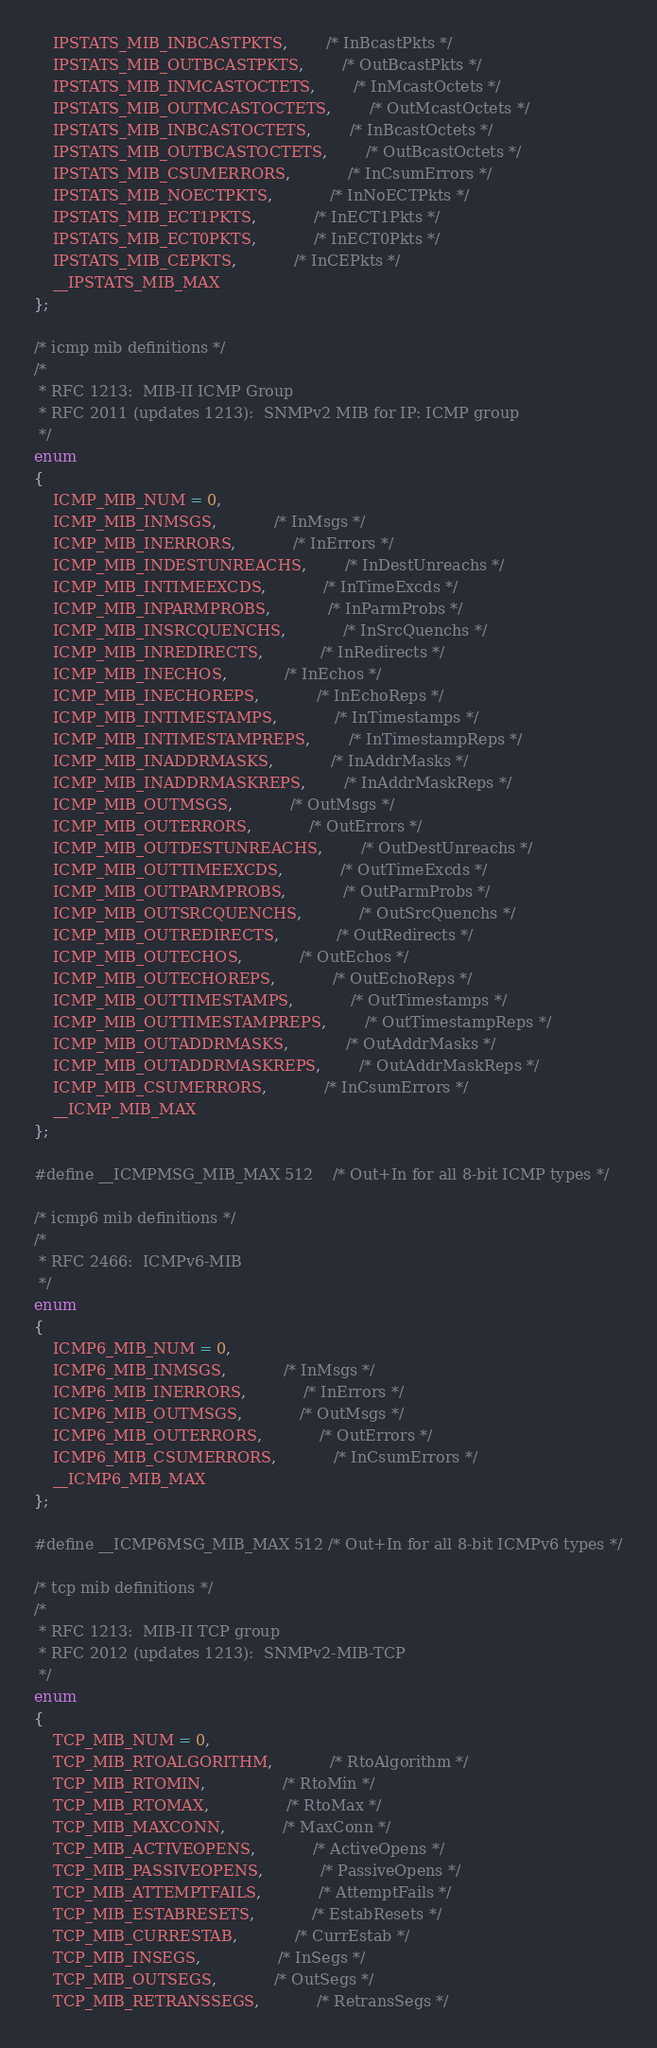<code> <loc_0><loc_0><loc_500><loc_500><_C_>	IPSTATS_MIB_INBCASTPKTS,		/* InBcastPkts */
	IPSTATS_MIB_OUTBCASTPKTS,		/* OutBcastPkts */
	IPSTATS_MIB_INMCASTOCTETS,		/* InMcastOctets */
	IPSTATS_MIB_OUTMCASTOCTETS,		/* OutMcastOctets */
	IPSTATS_MIB_INBCASTOCTETS,		/* InBcastOctets */
	IPSTATS_MIB_OUTBCASTOCTETS,		/* OutBcastOctets */
	IPSTATS_MIB_CSUMERRORS,			/* InCsumErrors */
	IPSTATS_MIB_NOECTPKTS,			/* InNoECTPkts */
	IPSTATS_MIB_ECT1PKTS,			/* InECT1Pkts */
	IPSTATS_MIB_ECT0PKTS,			/* InECT0Pkts */
	IPSTATS_MIB_CEPKTS,			/* InCEPkts */
	__IPSTATS_MIB_MAX
};

/* icmp mib definitions */
/*
 * RFC 1213:  MIB-II ICMP Group
 * RFC 2011 (updates 1213):  SNMPv2 MIB for IP: ICMP group
 */
enum
{
	ICMP_MIB_NUM = 0,
	ICMP_MIB_INMSGS,			/* InMsgs */
	ICMP_MIB_INERRORS,			/* InErrors */
	ICMP_MIB_INDESTUNREACHS,		/* InDestUnreachs */
	ICMP_MIB_INTIMEEXCDS,			/* InTimeExcds */
	ICMP_MIB_INPARMPROBS,			/* InParmProbs */
	ICMP_MIB_INSRCQUENCHS,			/* InSrcQuenchs */
	ICMP_MIB_INREDIRECTS,			/* InRedirects */
	ICMP_MIB_INECHOS,			/* InEchos */
	ICMP_MIB_INECHOREPS,			/* InEchoReps */
	ICMP_MIB_INTIMESTAMPS,			/* InTimestamps */
	ICMP_MIB_INTIMESTAMPREPS,		/* InTimestampReps */
	ICMP_MIB_INADDRMASKS,			/* InAddrMasks */
	ICMP_MIB_INADDRMASKREPS,		/* InAddrMaskReps */
	ICMP_MIB_OUTMSGS,			/* OutMsgs */
	ICMP_MIB_OUTERRORS,			/* OutErrors */
	ICMP_MIB_OUTDESTUNREACHS,		/* OutDestUnreachs */
	ICMP_MIB_OUTTIMEEXCDS,			/* OutTimeExcds */
	ICMP_MIB_OUTPARMPROBS,			/* OutParmProbs */
	ICMP_MIB_OUTSRCQUENCHS,			/* OutSrcQuenchs */
	ICMP_MIB_OUTREDIRECTS,			/* OutRedirects */
	ICMP_MIB_OUTECHOS,			/* OutEchos */
	ICMP_MIB_OUTECHOREPS,			/* OutEchoReps */
	ICMP_MIB_OUTTIMESTAMPS,			/* OutTimestamps */
	ICMP_MIB_OUTTIMESTAMPREPS,		/* OutTimestampReps */
	ICMP_MIB_OUTADDRMASKS,			/* OutAddrMasks */
	ICMP_MIB_OUTADDRMASKREPS,		/* OutAddrMaskReps */
	ICMP_MIB_CSUMERRORS,			/* InCsumErrors */
	__ICMP_MIB_MAX
};

#define __ICMPMSG_MIB_MAX 512	/* Out+In for all 8-bit ICMP types */

/* icmp6 mib definitions */
/*
 * RFC 2466:  ICMPv6-MIB
 */
enum
{
	ICMP6_MIB_NUM = 0,
	ICMP6_MIB_INMSGS,			/* InMsgs */
	ICMP6_MIB_INERRORS,			/* InErrors */
	ICMP6_MIB_OUTMSGS,			/* OutMsgs */
	ICMP6_MIB_OUTERRORS,			/* OutErrors */
	ICMP6_MIB_CSUMERRORS,			/* InCsumErrors */
	__ICMP6_MIB_MAX
};

#define __ICMP6MSG_MIB_MAX 512 /* Out+In for all 8-bit ICMPv6 types */

/* tcp mib definitions */
/*
 * RFC 1213:  MIB-II TCP group
 * RFC 2012 (updates 1213):  SNMPv2-MIB-TCP
 */
enum
{
	TCP_MIB_NUM = 0,
	TCP_MIB_RTOALGORITHM,			/* RtoAlgorithm */
	TCP_MIB_RTOMIN,				/* RtoMin */
	TCP_MIB_RTOMAX,				/* RtoMax */
	TCP_MIB_MAXCONN,			/* MaxConn */
	TCP_MIB_ACTIVEOPENS,			/* ActiveOpens */
	TCP_MIB_PASSIVEOPENS,			/* PassiveOpens */
	TCP_MIB_ATTEMPTFAILS,			/* AttemptFails */
	TCP_MIB_ESTABRESETS,			/* EstabResets */
	TCP_MIB_CURRESTAB,			/* CurrEstab */
	TCP_MIB_INSEGS,				/* InSegs */
	TCP_MIB_OUTSEGS,			/* OutSegs */
	TCP_MIB_RETRANSSEGS,			/* RetransSegs */</code> 